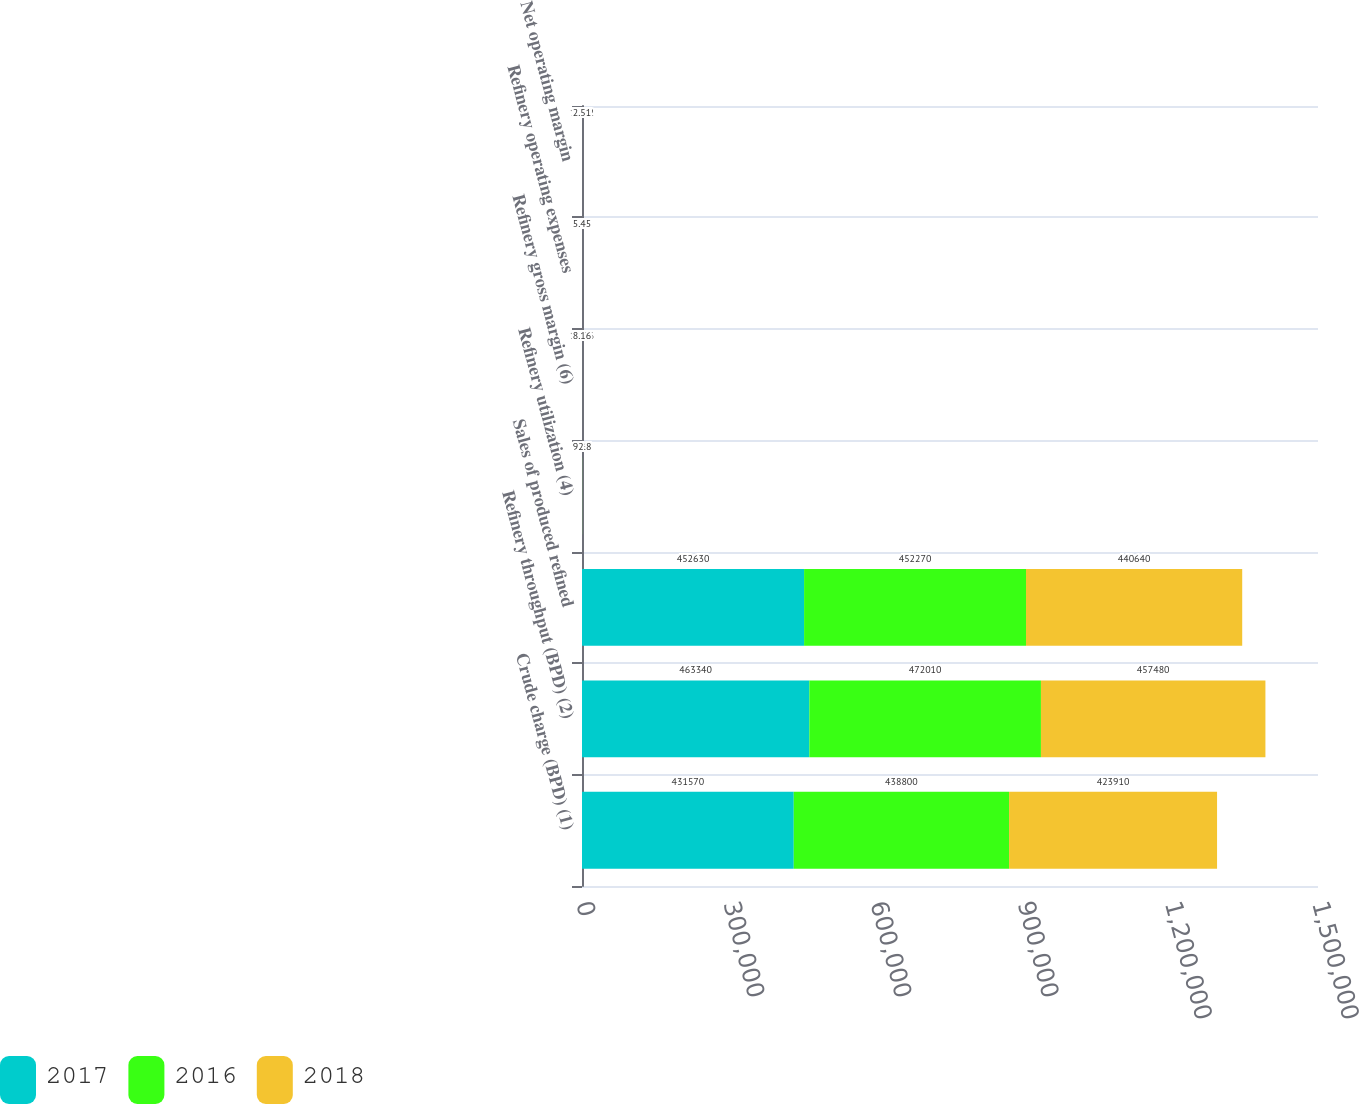Convert chart. <chart><loc_0><loc_0><loc_500><loc_500><stacked_bar_chart><ecel><fcel>Crude charge (BPD) (1)<fcel>Refinery throughput (BPD) (2)<fcel>Sales of produced refined<fcel>Refinery utilization (4)<fcel>Refinery gross margin (6)<fcel>Refinery operating expenses<fcel>Net operating margin<nl><fcel>2017<fcel>431570<fcel>463340<fcel>452630<fcel>94.4<fcel>17.71<fcel>6.24<fcel>11.32<nl><fcel>2016<fcel>438800<fcel>472010<fcel>452270<fcel>96<fcel>11.56<fcel>5.86<fcel>5.45<nl><fcel>2018<fcel>423910<fcel>457480<fcel>440640<fcel>92.8<fcel>8.16<fcel>5.45<fcel>2.51<nl></chart> 